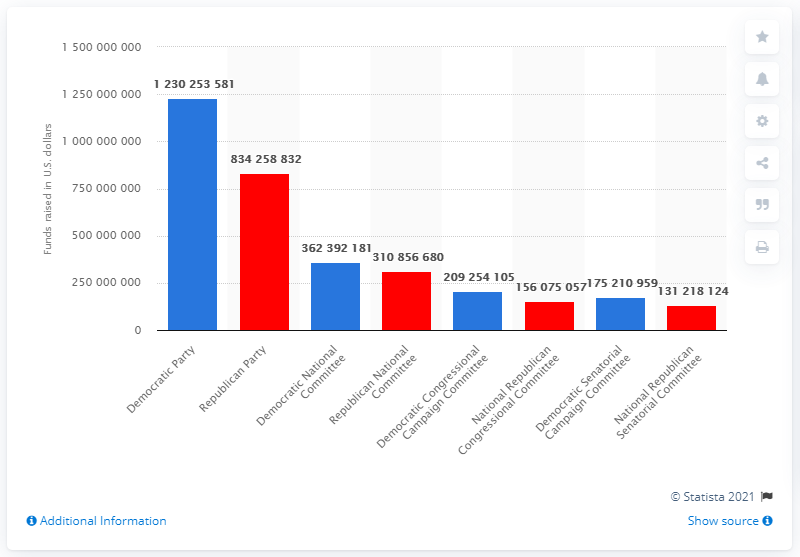Point out several critical features in this image. The Democratic Party spent a significant amount of money during the 2016 election cycle. Specifically, the party spent $1,230,253,581. 